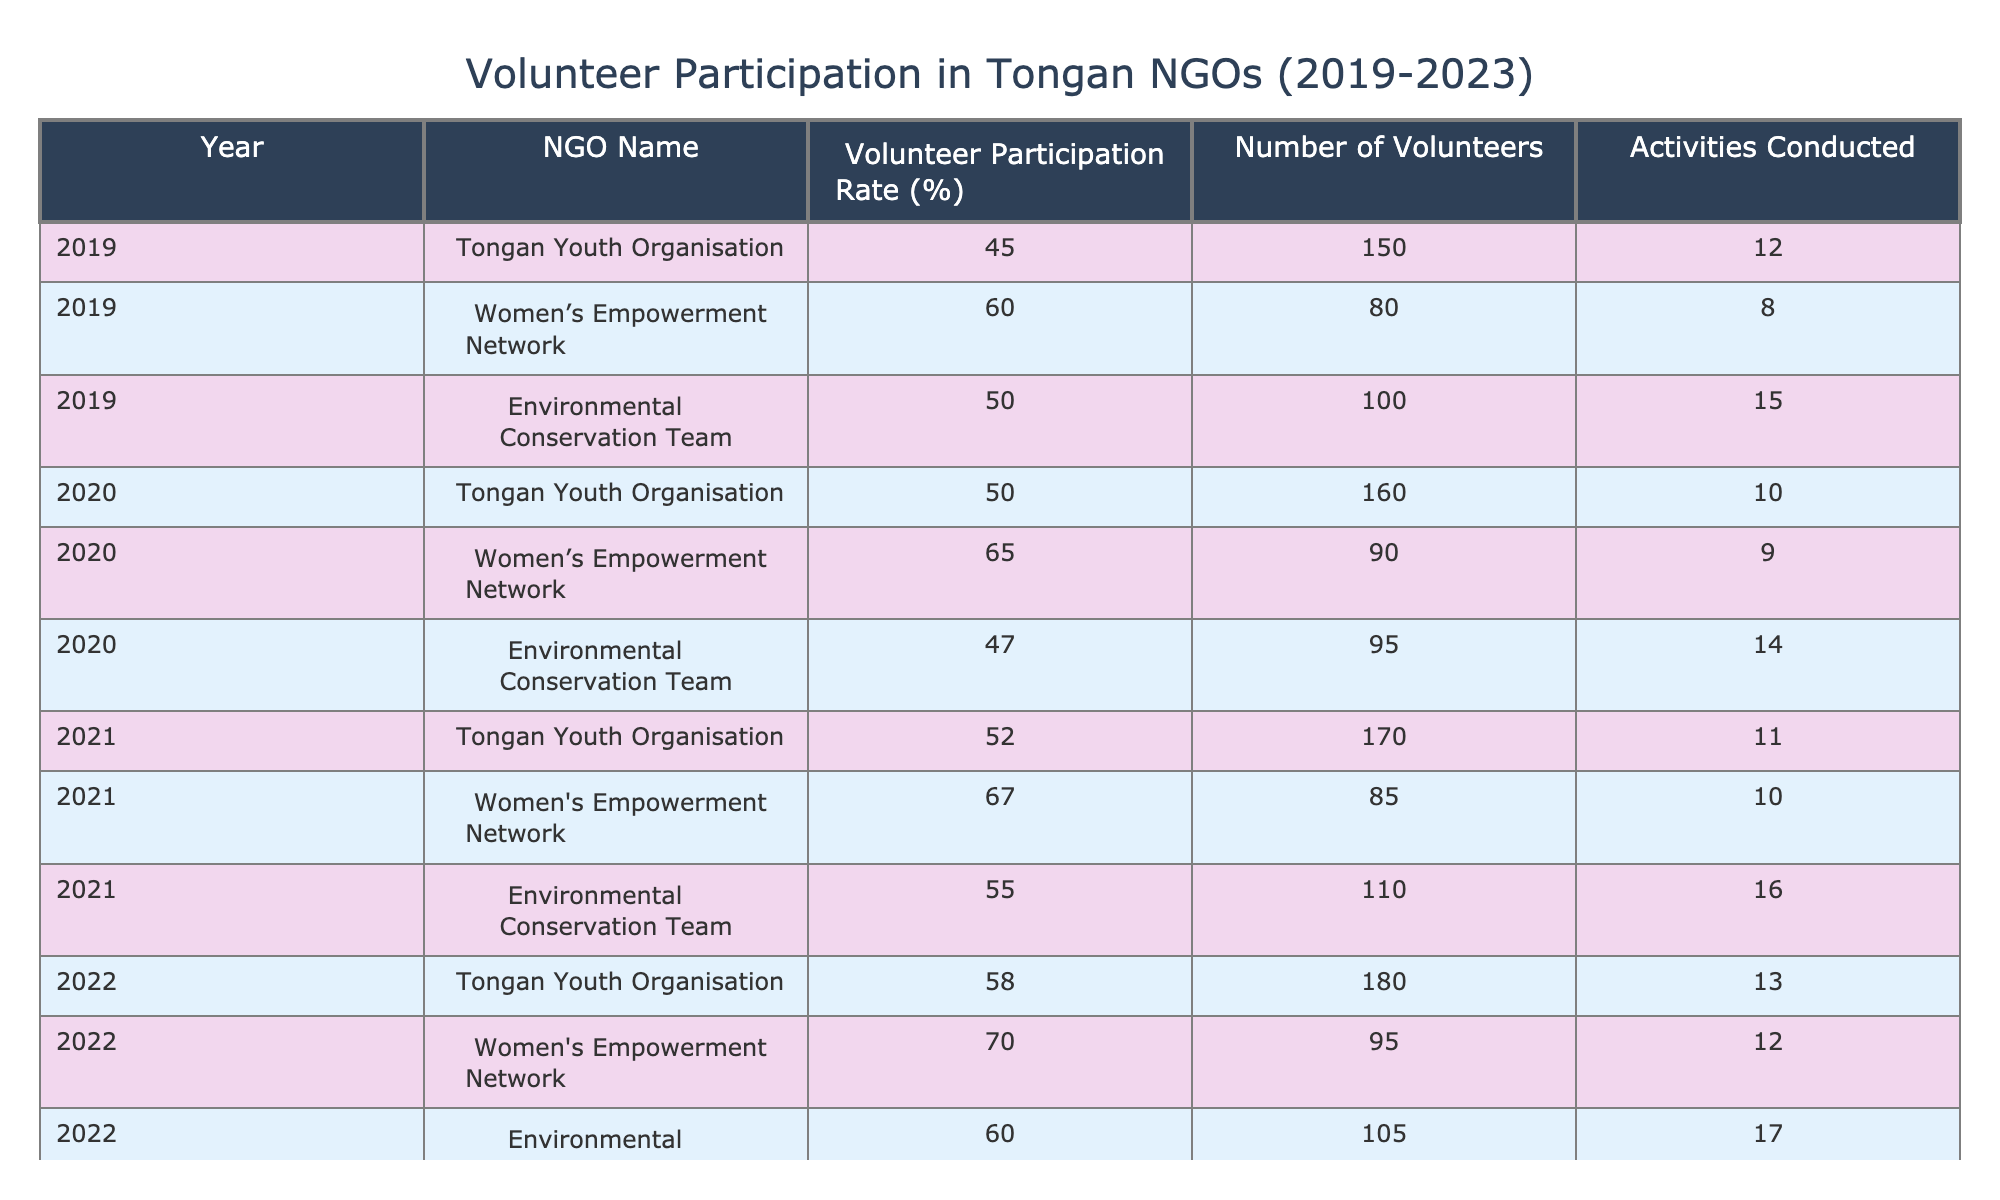What was the volunteer participation rate for the Women's Empowerment Network in 2021? In the table, I look under the "Year" column for 2021 and find the corresponding row for the Women's Empowerment Network. The "Volunteer Participation Rate (%)" for that row is 67.
Answer: 67 Which NGO had the highest volunteer participation rate in 2022? Checking the "Volunteer Participation Rate (%)" column for the year 2022, I see the Women's Empowerment Network had a rate of 70, which is the highest among the NGOs listed for that year.
Answer: Women's Empowerment Network How many activities were conducted by the Environmental Conservation Team in 2020? I find the row for the Environmental Conservation Team under the year 2020. The "Activities Conducted" column indicates that they conducted 14 activities that year.
Answer: 14 What was the average volunteer participation rate across all NGOs in 2023? To find the average, I first sum the volunteer participation rates for 2023: 60 (Tongan Youth Organisation) + 72 (Women's Empowerment Network) + 62 (Environmental Conservation Team) = 194. Then, I divide by the number of NGOs, which is 3, yielding 194 / 3 = 64.67.
Answer: 64.67 Did the number of volunteers increase in the Tongan Youth Organisation from 2019 to 2023? I check the number of volunteers for the Tongan Youth Organisation in the years 2019 and 2023. In 2019, there were 150 volunteers, and in 2023, there were 190. Since 190 is greater than 150, the number of volunteers did indeed increase.
Answer: Yes Which year saw the largest increase in volunteer participation rate for the Environmental Conservation Team compared to the previous year? I compare the volunteer participation rates for the Environmental Conservation Team across the years: 2019 (50), 2020 (47), 2021 (55), 2022 (60), 2023 (62). The largest increase occurs from 2020 to 2021, where the rate goes from 47 to 55, an increase of 8 percentage points.
Answer: 2021 What was the volunteer participation rate change for the Women's Empowerment Network from 2019 to 2023? The participation rate for the Women's Empowerment Network in 2019 was 60%, and in 2023 it was 72%. I calculate the change by subtracting the earlier rate from the later rate: 72 - 60 = 12. The participation rate increased by 12 percentage points.
Answer: 12 Which NGO had the lowest number of volunteers in 2022? I look at the "Number of Volunteers" column for the year 2022. The Women's Empowerment Network had the lowest number with 95, compared to Tongan Youth Organisation with 180 and Environmental Conservation Team with 105.
Answer: Women's Empowerment Network What is the total number of activities conducted by Tongan Youth Organisation from 2019 to 2023? I sum the activities conducted by the Tongan Youth Organisation over the years: 12 (2019) + 10 (2020) + 11 (2021) + 13 (2022) + 14 (2023) = 60. Therefore, the total number of activities conducted is 60.
Answer: 60 